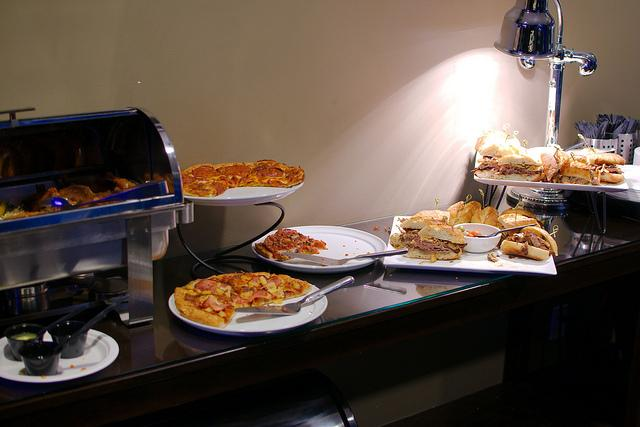What kind of service was this? buffet 